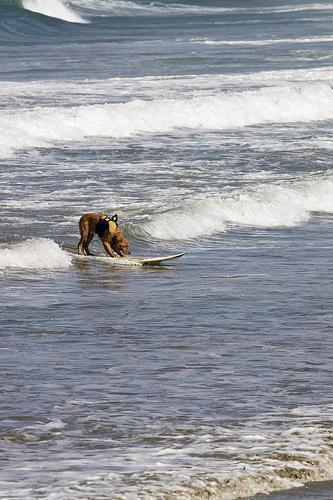How many dogs are there?
Give a very brief answer. 1. 